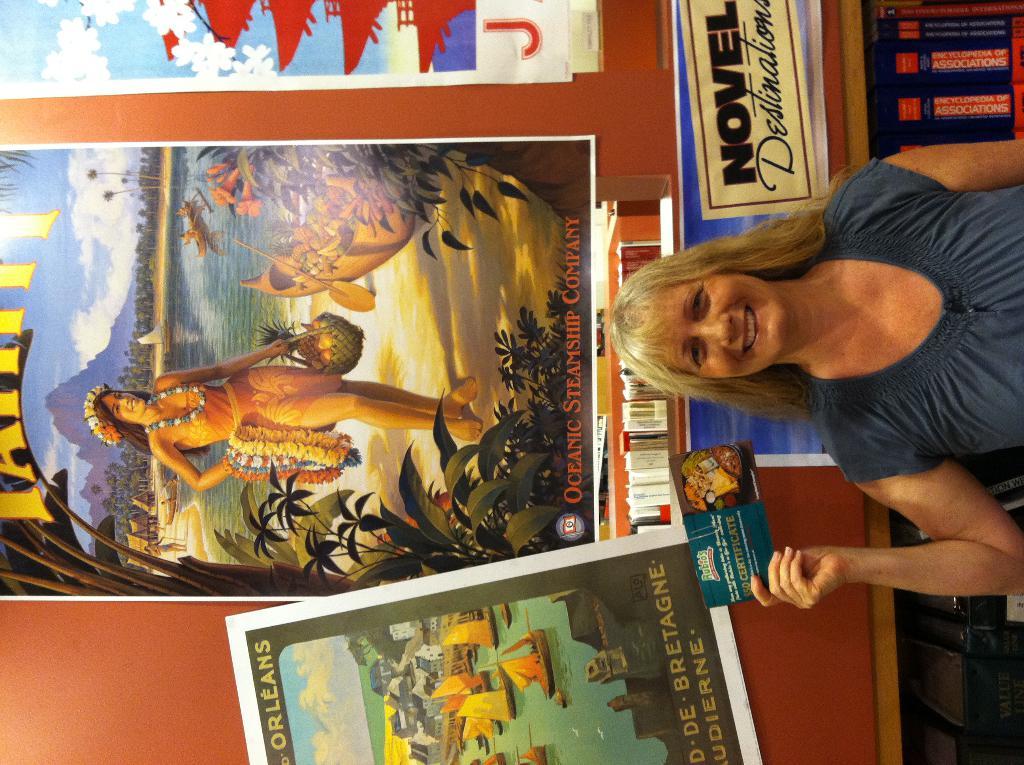What company made the biggest poster, the one right above the lady's head?
Your response must be concise. Oceanic steamship company. Where was the sign being advertised?
Offer a terse response. Hawaii. 